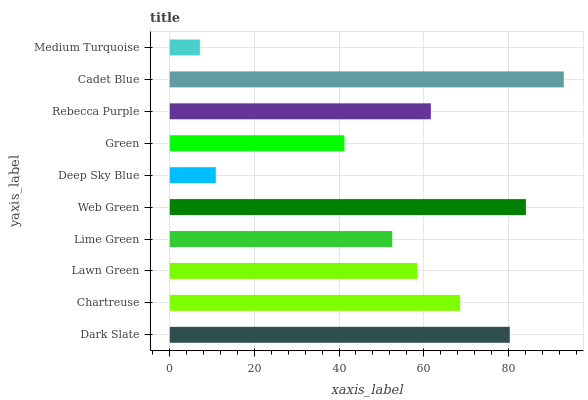Is Medium Turquoise the minimum?
Answer yes or no. Yes. Is Cadet Blue the maximum?
Answer yes or no. Yes. Is Chartreuse the minimum?
Answer yes or no. No. Is Chartreuse the maximum?
Answer yes or no. No. Is Dark Slate greater than Chartreuse?
Answer yes or no. Yes. Is Chartreuse less than Dark Slate?
Answer yes or no. Yes. Is Chartreuse greater than Dark Slate?
Answer yes or no. No. Is Dark Slate less than Chartreuse?
Answer yes or no. No. Is Rebecca Purple the high median?
Answer yes or no. Yes. Is Lawn Green the low median?
Answer yes or no. Yes. Is Deep Sky Blue the high median?
Answer yes or no. No. Is Rebecca Purple the low median?
Answer yes or no. No. 